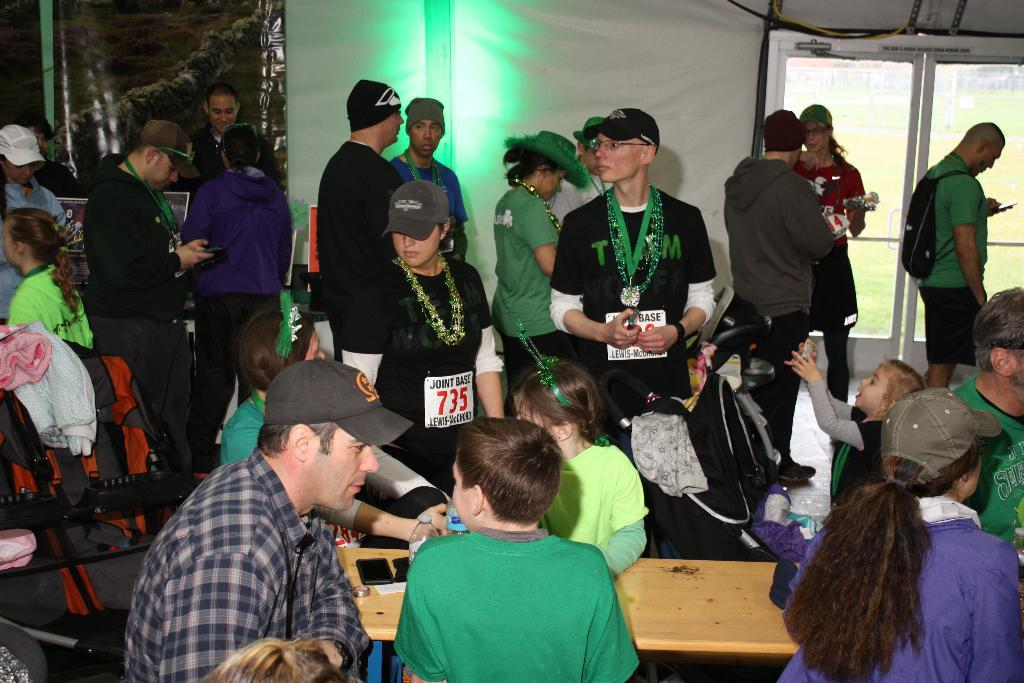How many people are in the image? There are multiple people in the image. What are the people wearing on their heads? Most of the people are wearing caps. What object can be seen in the image that might be used for eating or working? There is a table in the image. What type of items can be seen in the image that might be related to clothing? There are clothes visible in the image. What type of polish is being applied to the fan in the image? There is no polish or fan present in the image. How many pears are visible on the table in the image? There are no pears visible on the table in the image. 